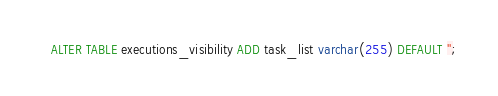Convert code to text. <code><loc_0><loc_0><loc_500><loc_500><_SQL_>ALTER TABLE executions_visibility ADD task_list varchar(255) DEFAULT '';</code> 